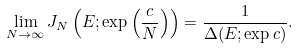<formula> <loc_0><loc_0><loc_500><loc_500>\lim _ { N \to \infty } J _ { N } \left ( E ; \exp \left ( \frac { c } { N } \right ) \right ) = \frac { 1 } { \Delta ( E ; \exp { c } ) } .</formula> 